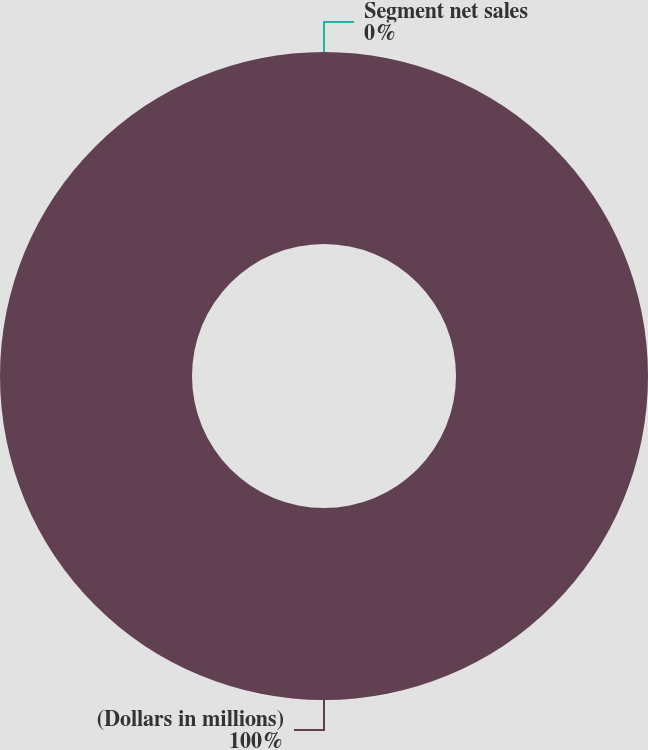<chart> <loc_0><loc_0><loc_500><loc_500><pie_chart><fcel>(Dollars in millions)<fcel>Segment net sales<nl><fcel>100.0%<fcel>0.0%<nl></chart> 